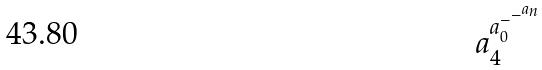<formula> <loc_0><loc_0><loc_500><loc_500>a _ { 4 } ^ { a _ { 0 } ^ { - ^ { - ^ { a _ { n } } } } }</formula> 